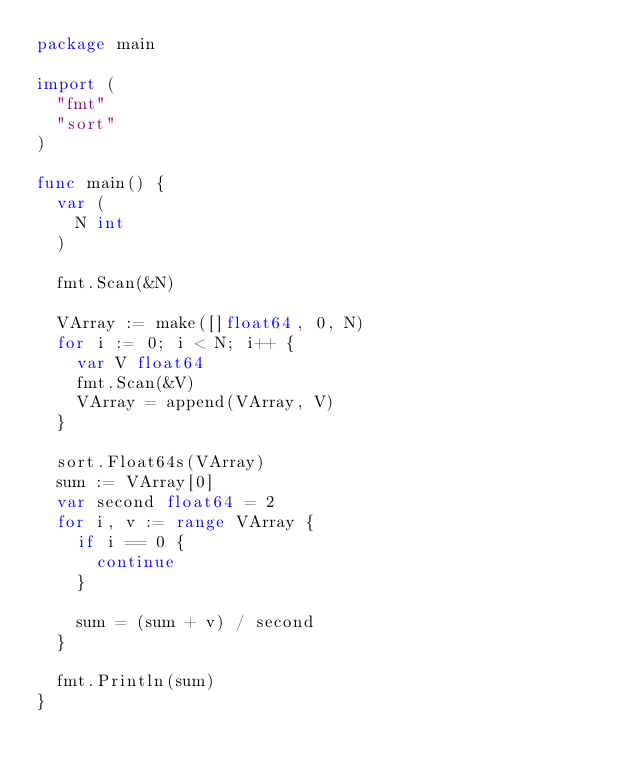<code> <loc_0><loc_0><loc_500><loc_500><_Go_>package main

import (
	"fmt"
	"sort"
)

func main() {
	var (
		N int
	)

	fmt.Scan(&N)

	VArray := make([]float64, 0, N)
	for i := 0; i < N; i++ {
		var V float64
		fmt.Scan(&V)
		VArray = append(VArray, V)
	}

	sort.Float64s(VArray)
	sum := VArray[0]
	var second float64 = 2
	for i, v := range VArray {
		if i == 0 {
			continue
		}

		sum = (sum + v) / second
	}

	fmt.Println(sum)
}
</code> 